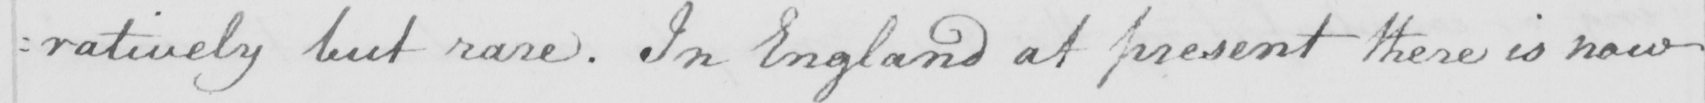What text is written in this handwritten line? : ratively but rare . In England at present there is now 